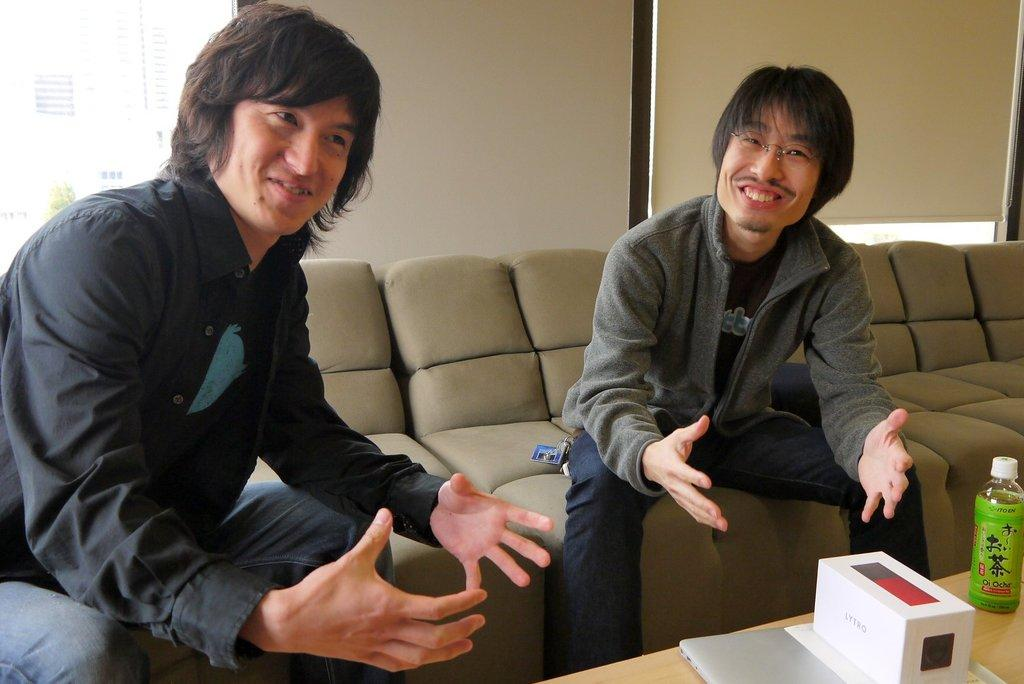How many people are seated on the sofa bed in the image? There are two men seated on the sofa bed in the image. What objects are on the table in the image? There is a bottle, a box, and a laptop on the table in the image. How does the digestion process of the giants affect the sofa bed in the image? There are no giants present in the image, and therefore their digestion process cannot affect the sofa bed. 